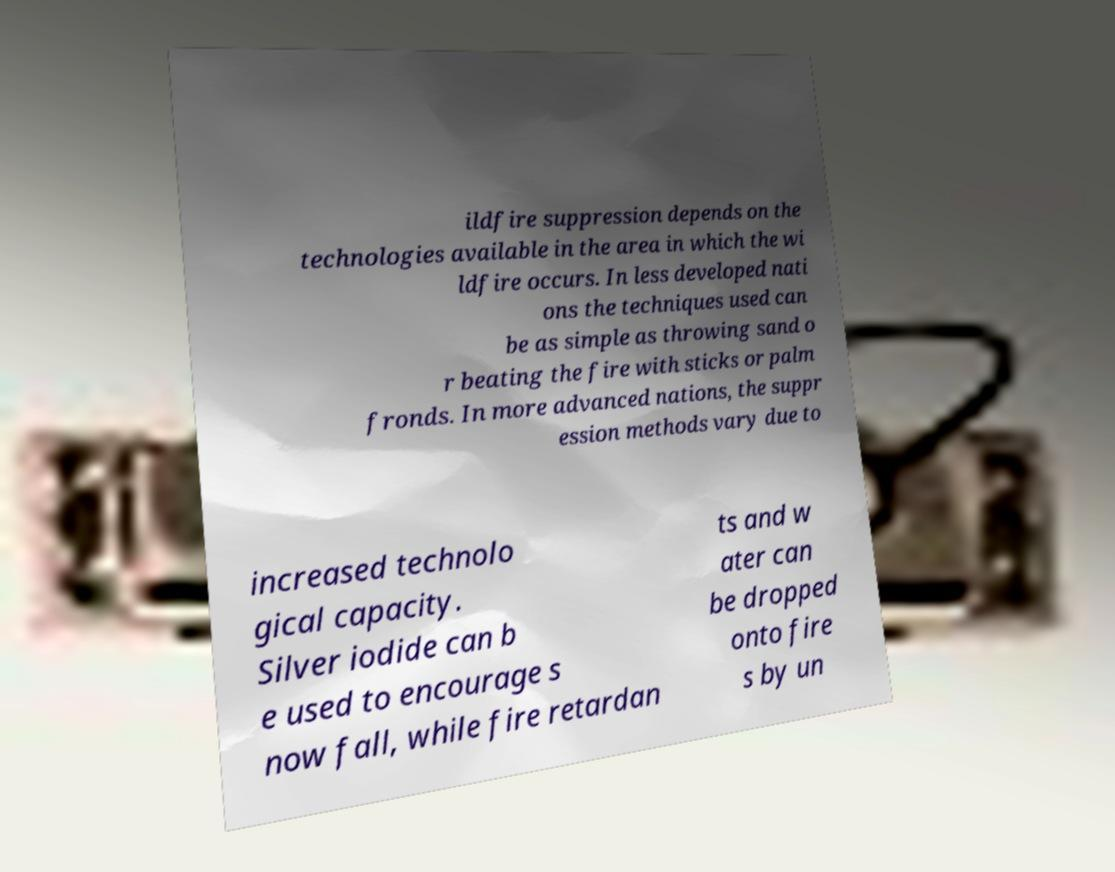What messages or text are displayed in this image? I need them in a readable, typed format. ildfire suppression depends on the technologies available in the area in which the wi ldfire occurs. In less developed nati ons the techniques used can be as simple as throwing sand o r beating the fire with sticks or palm fronds. In more advanced nations, the suppr ession methods vary due to increased technolo gical capacity. Silver iodide can b e used to encourage s now fall, while fire retardan ts and w ater can be dropped onto fire s by un 